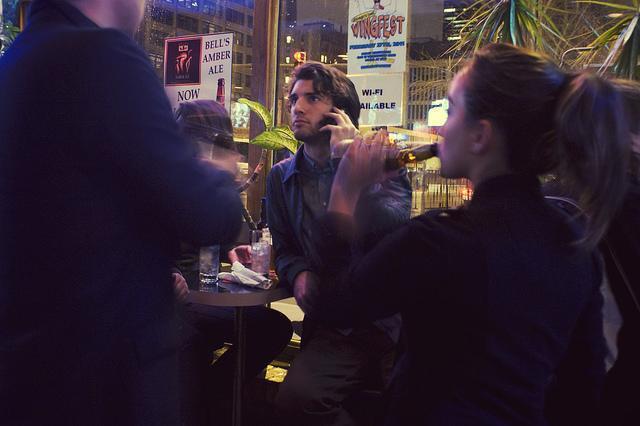How many people are visible?
Give a very brief answer. 4. 